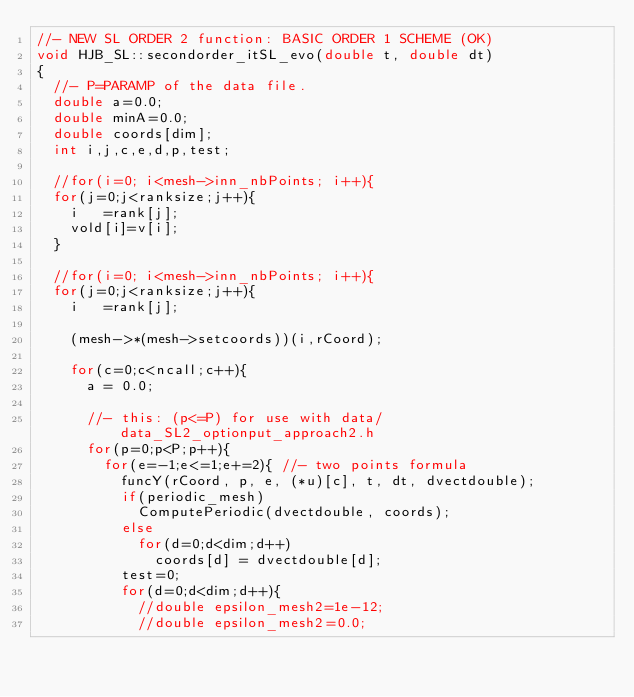<code> <loc_0><loc_0><loc_500><loc_500><_C_>//- NEW SL ORDER 2 function: BASIC ORDER 1 SCHEME (OK)
void HJB_SL::secondorder_itSL_evo(double t, double dt)
{
  //- P=PARAMP of the data file.
  double a=0.0;
  double minA=0.0;
  double coords[dim];
  int i,j,c,e,d,p,test;

  //for(i=0; i<mesh->inn_nbPoints; i++){
  for(j=0;j<ranksize;j++){
    i   =rank[j];
    vold[i]=v[i];
  }

  //for(i=0; i<mesh->inn_nbPoints; i++){
  for(j=0;j<ranksize;j++){
    i   =rank[j];

    (mesh->*(mesh->setcoords))(i,rCoord);

    for(c=0;c<ncall;c++){
      a = 0.0;

      //- this: (p<=P) for use with data/data_SL2_optionput_approach2.h
      for(p=0;p<P;p++){
        for(e=-1;e<=1;e+=2){ //- two points formula
          funcY(rCoord, p, e, (*u)[c], t, dt, dvectdouble);
          if(periodic_mesh)
            ComputePeriodic(dvectdouble, coords);
          else
            for(d=0;d<dim;d++)
              coords[d] = dvectdouble[d];
          test=0;
          for(d=0;d<dim;d++){
            //double epsilon_mesh2=1e-12;
            //double epsilon_mesh2=0.0;</code> 